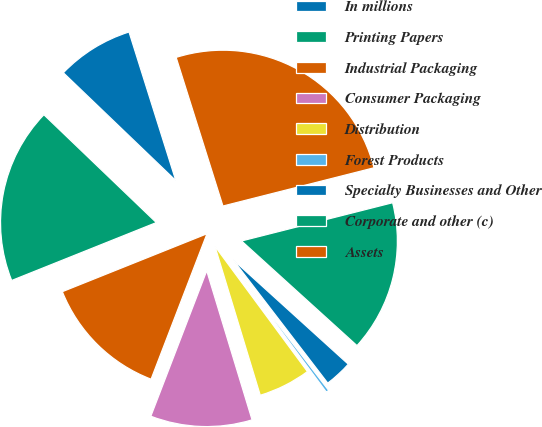Convert chart. <chart><loc_0><loc_0><loc_500><loc_500><pie_chart><fcel>In millions<fcel>Printing Papers<fcel>Industrial Packaging<fcel>Consumer Packaging<fcel>Distribution<fcel>Forest Products<fcel>Specialty Businesses and Other<fcel>Corporate and other (c)<fcel>Assets<nl><fcel>7.98%<fcel>18.23%<fcel>13.1%<fcel>10.54%<fcel>5.42%<fcel>0.3%<fcel>2.86%<fcel>15.67%<fcel>25.91%<nl></chart> 